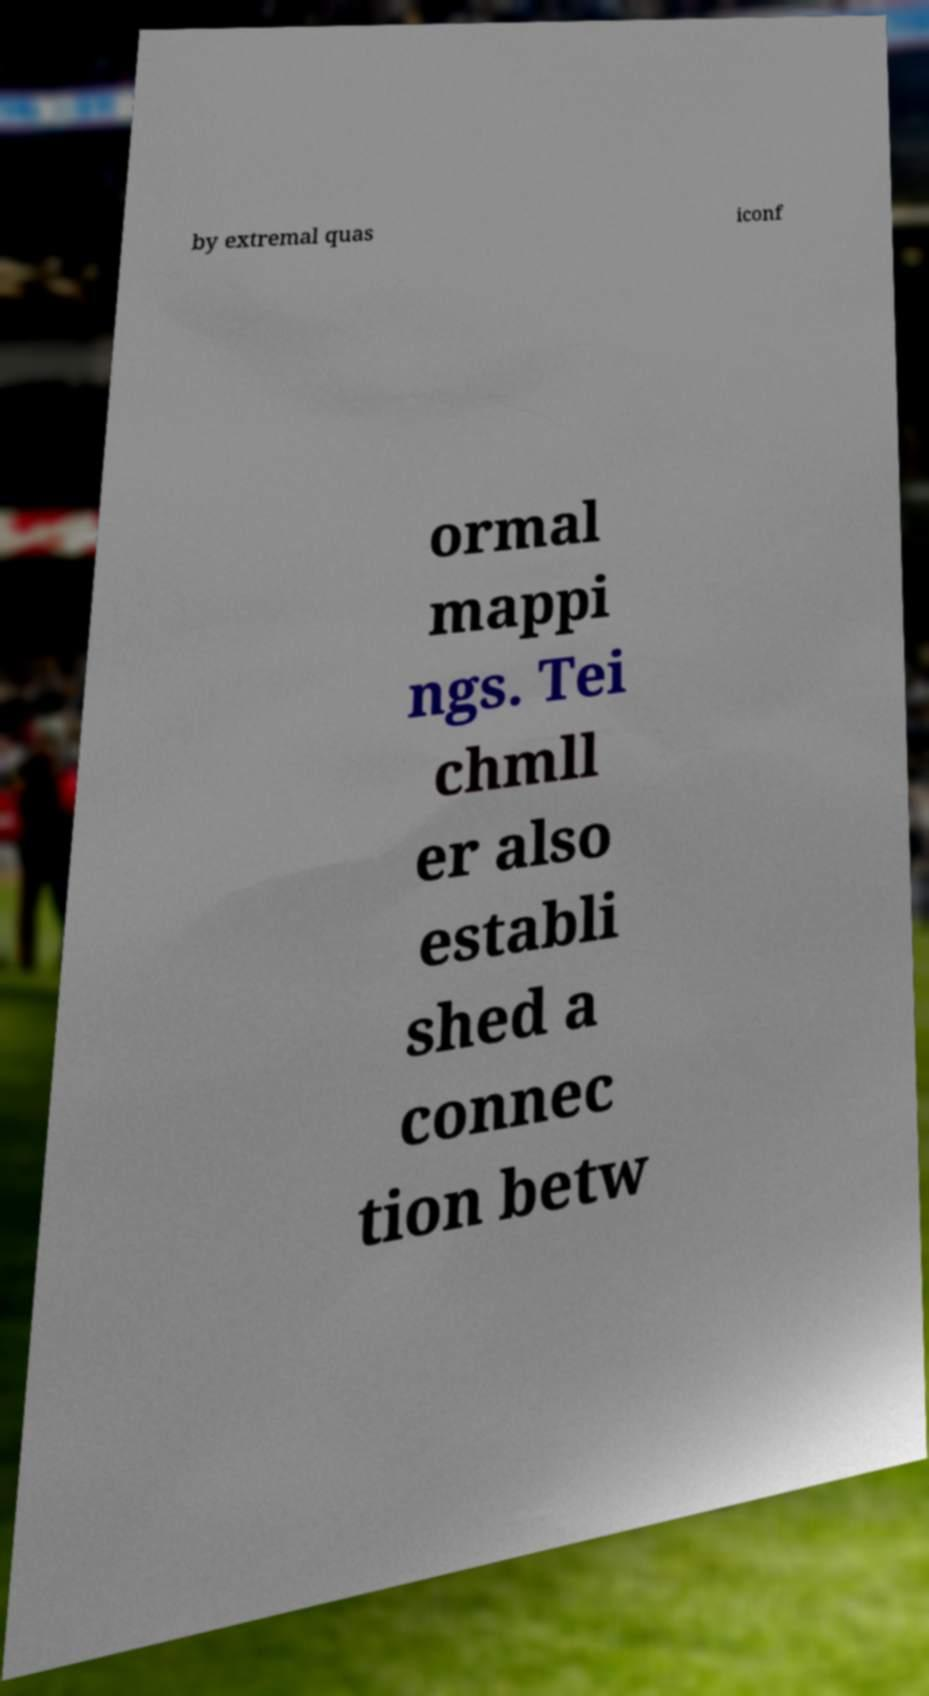Could you extract and type out the text from this image? by extremal quas iconf ormal mappi ngs. Tei chmll er also establi shed a connec tion betw 